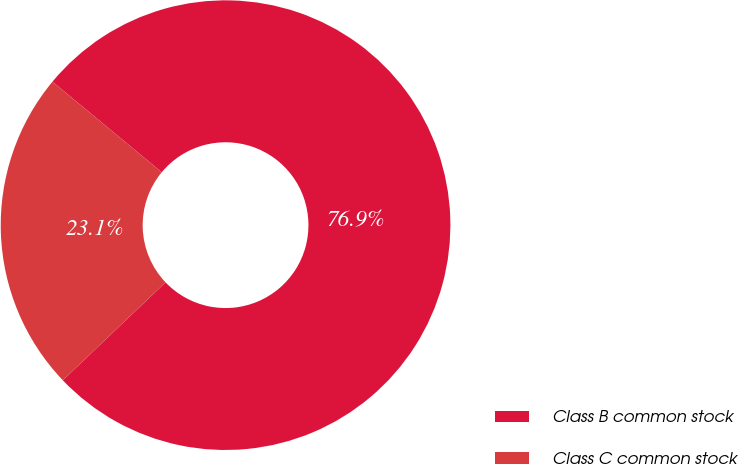Convert chart. <chart><loc_0><loc_0><loc_500><loc_500><pie_chart><fcel>Class B common stock<fcel>Class C common stock<nl><fcel>76.87%<fcel>23.13%<nl></chart> 